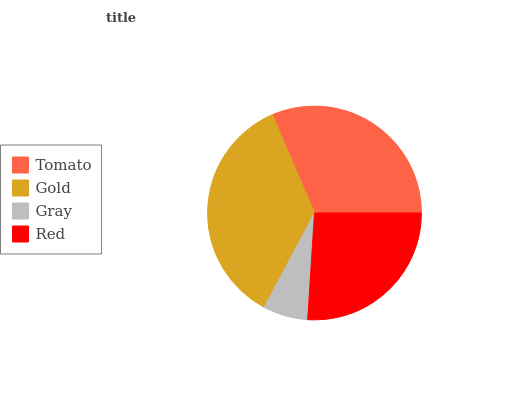Is Gray the minimum?
Answer yes or no. Yes. Is Gold the maximum?
Answer yes or no. Yes. Is Gold the minimum?
Answer yes or no. No. Is Gray the maximum?
Answer yes or no. No. Is Gold greater than Gray?
Answer yes or no. Yes. Is Gray less than Gold?
Answer yes or no. Yes. Is Gray greater than Gold?
Answer yes or no. No. Is Gold less than Gray?
Answer yes or no. No. Is Tomato the high median?
Answer yes or no. Yes. Is Red the low median?
Answer yes or no. Yes. Is Gray the high median?
Answer yes or no. No. Is Tomato the low median?
Answer yes or no. No. 